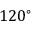<formula> <loc_0><loc_0><loc_500><loc_500>1 2 0 ^ { \circ }</formula> 